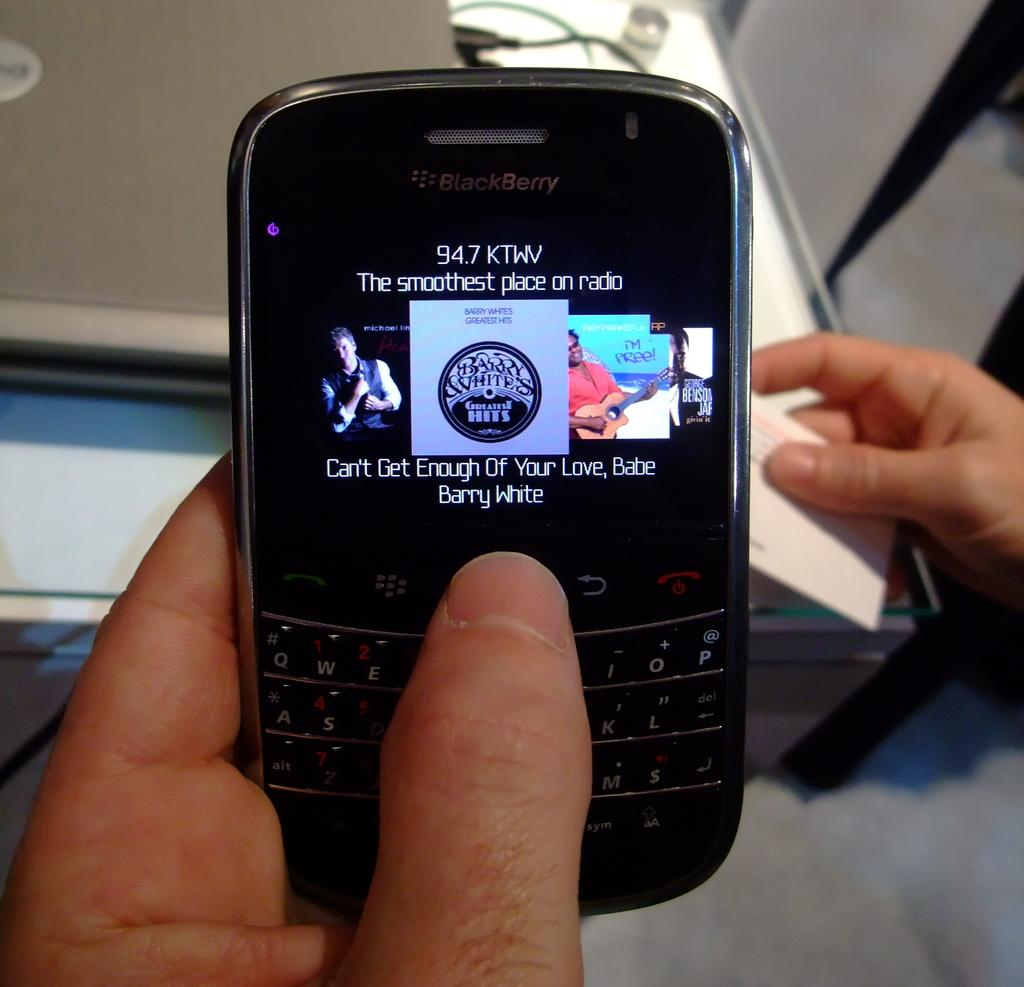<image>
Share a concise interpretation of the image provided. a Blackberry cell phone open to a page with a Barry White song 